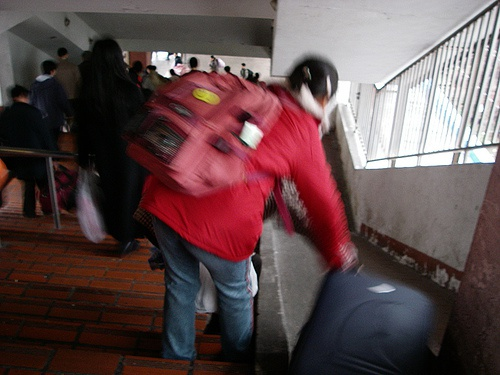Describe the objects in this image and their specific colors. I can see people in gray, brown, black, and maroon tones, backpack in gray, brown, black, maroon, and salmon tones, suitcase in gray, black, and darkblue tones, people in gray, black, and maroon tones, and people in gray, black, maroon, and brown tones in this image. 